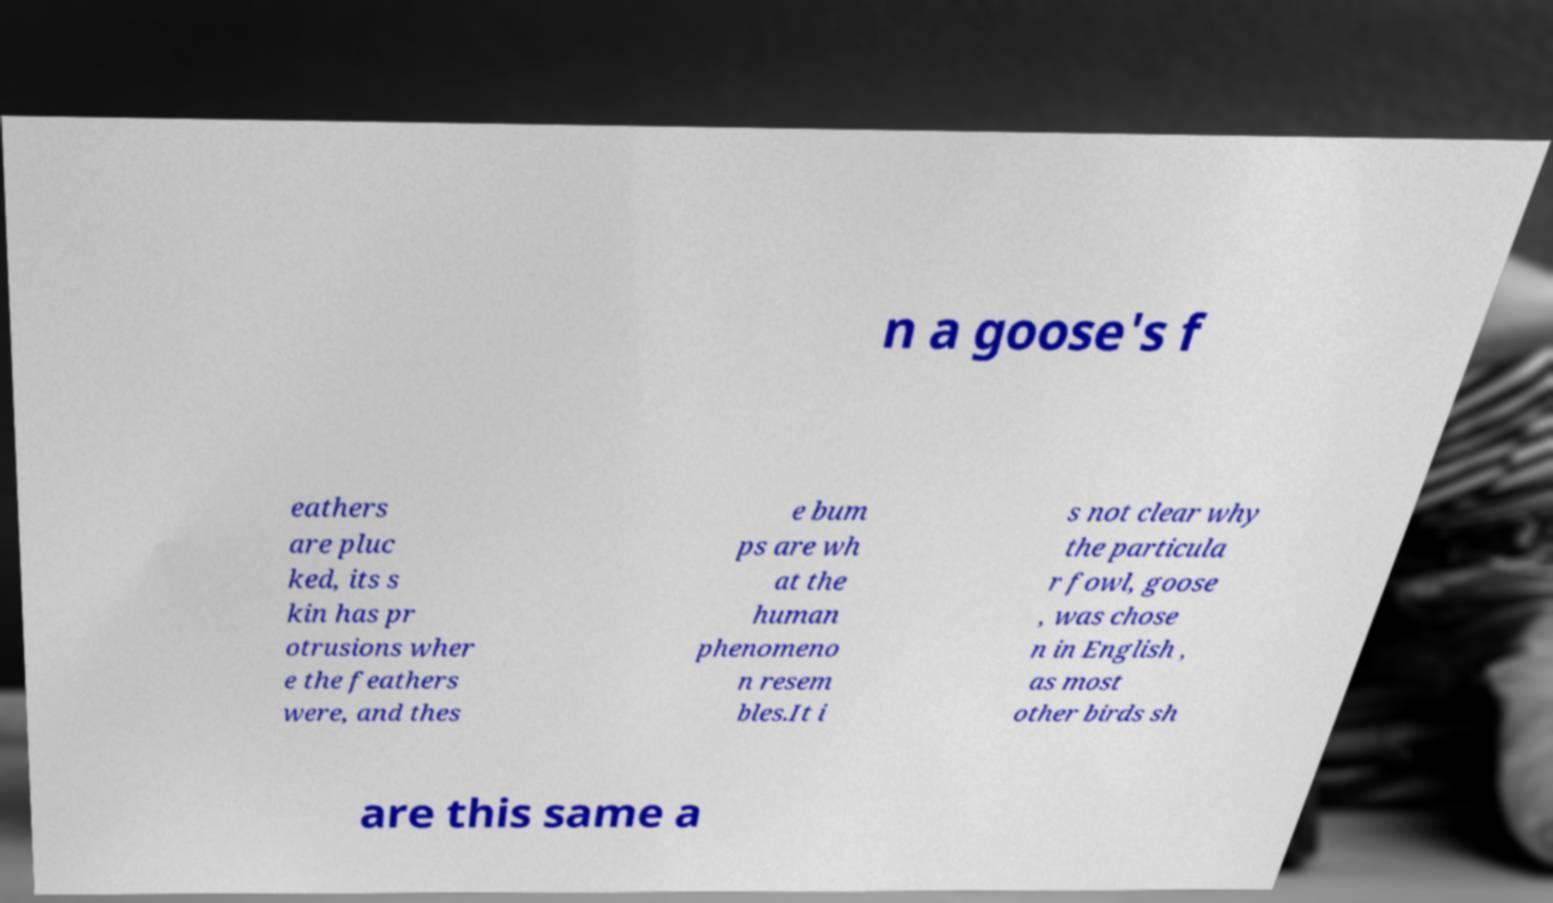Can you accurately transcribe the text from the provided image for me? n a goose's f eathers are pluc ked, its s kin has pr otrusions wher e the feathers were, and thes e bum ps are wh at the human phenomeno n resem bles.It i s not clear why the particula r fowl, goose , was chose n in English , as most other birds sh are this same a 